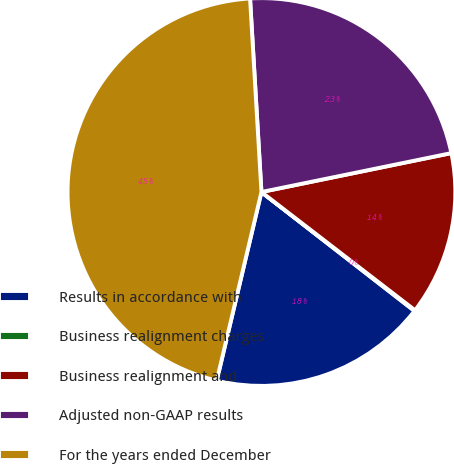<chart> <loc_0><loc_0><loc_500><loc_500><pie_chart><fcel>Results in accordance with<fcel>Business realignment charges<fcel>Business realignment and<fcel>Adjusted non-GAAP results<fcel>For the years ended December<nl><fcel>18.19%<fcel>0.07%<fcel>13.66%<fcel>22.72%<fcel>45.36%<nl></chart> 